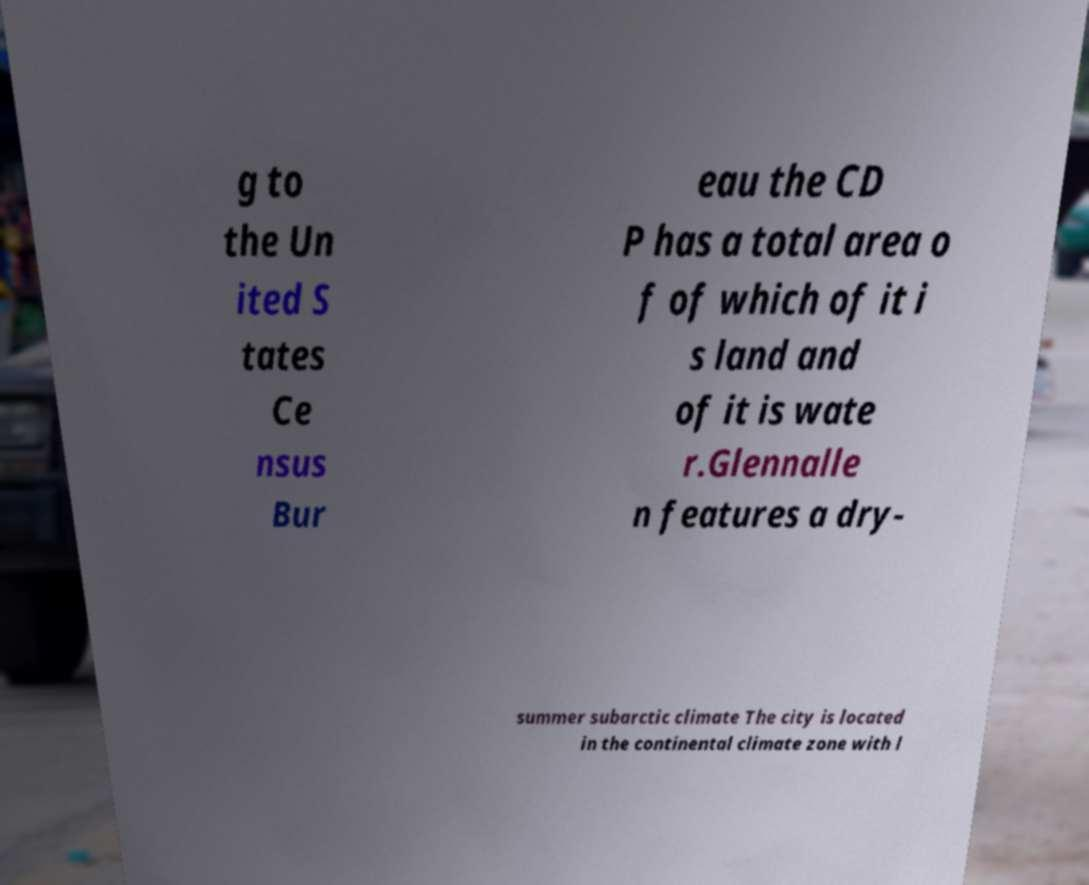Please identify and transcribe the text found in this image. g to the Un ited S tates Ce nsus Bur eau the CD P has a total area o f of which of it i s land and of it is wate r.Glennalle n features a dry- summer subarctic climate The city is located in the continental climate zone with l 